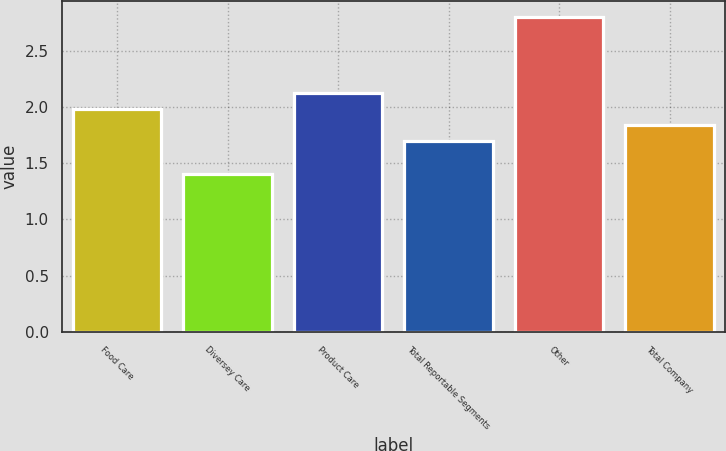Convert chart to OTSL. <chart><loc_0><loc_0><loc_500><loc_500><bar_chart><fcel>Food Care<fcel>Diversey Care<fcel>Product Care<fcel>Total Reportable Segments<fcel>Other<fcel>Total Company<nl><fcel>1.98<fcel>1.4<fcel>2.12<fcel>1.7<fcel>2.8<fcel>1.84<nl></chart> 